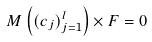<formula> <loc_0><loc_0><loc_500><loc_500>M \left ( ( c _ { j } ) _ { j = 1 } ^ { l } \right ) \times F = 0</formula> 